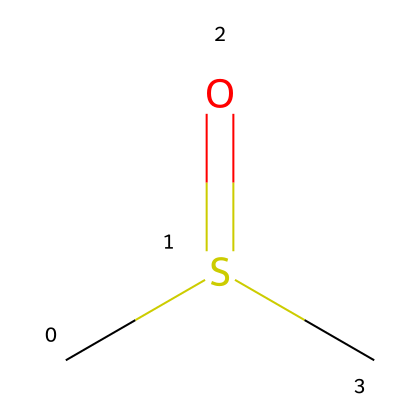What is the molecular formula of this compound? From the SMILES representation CS(=O)C, you can identify that this compound contains two carbon atoms (C), one sulfur atom (S), and one oxygen atom (O), leading to a molecular formula of C2H6OS when counting all hydrogen atoms connected to the carbons.
Answer: C2H6OS How many atoms of sulfur are in the structure? Based on the SMILES, there is one 'S' for sulfur, indicating only one sulfur atom is present in the chemical structure.
Answer: 1 What type of functional group is present in this compound? Analyzing the structure, the 'S(=O)' indicates the presence of a sulfoxide functional group, which is characteristic for compounds like dimethyl sulfoxide.
Answer: sulfoxide What is the total number of hydrogen atoms in the structure? In the SMILES representation, for each carbon atom, it is bonded to enough hydrogen atoms to satisfy carbon's four-valence shell requirement. For the two carbon atoms indicated, there are a total of six hydrogen atoms in C2H6OS.
Answer: 6 How many bonds are present between the sulfur and oxygen atoms? The structure shows 'S(=O)', denoting a double bond between sulfur and oxygen, indicating there is one bond of this type.
Answer: 1 Is this compound polar or non-polar? The presence of the sulfur-oxygen bond introduces polarity to the molecule due to the difference in electronegativity between sulfur and oxygen, along with the overall shape of the molecule, indicating it is polar.
Answer: polar 